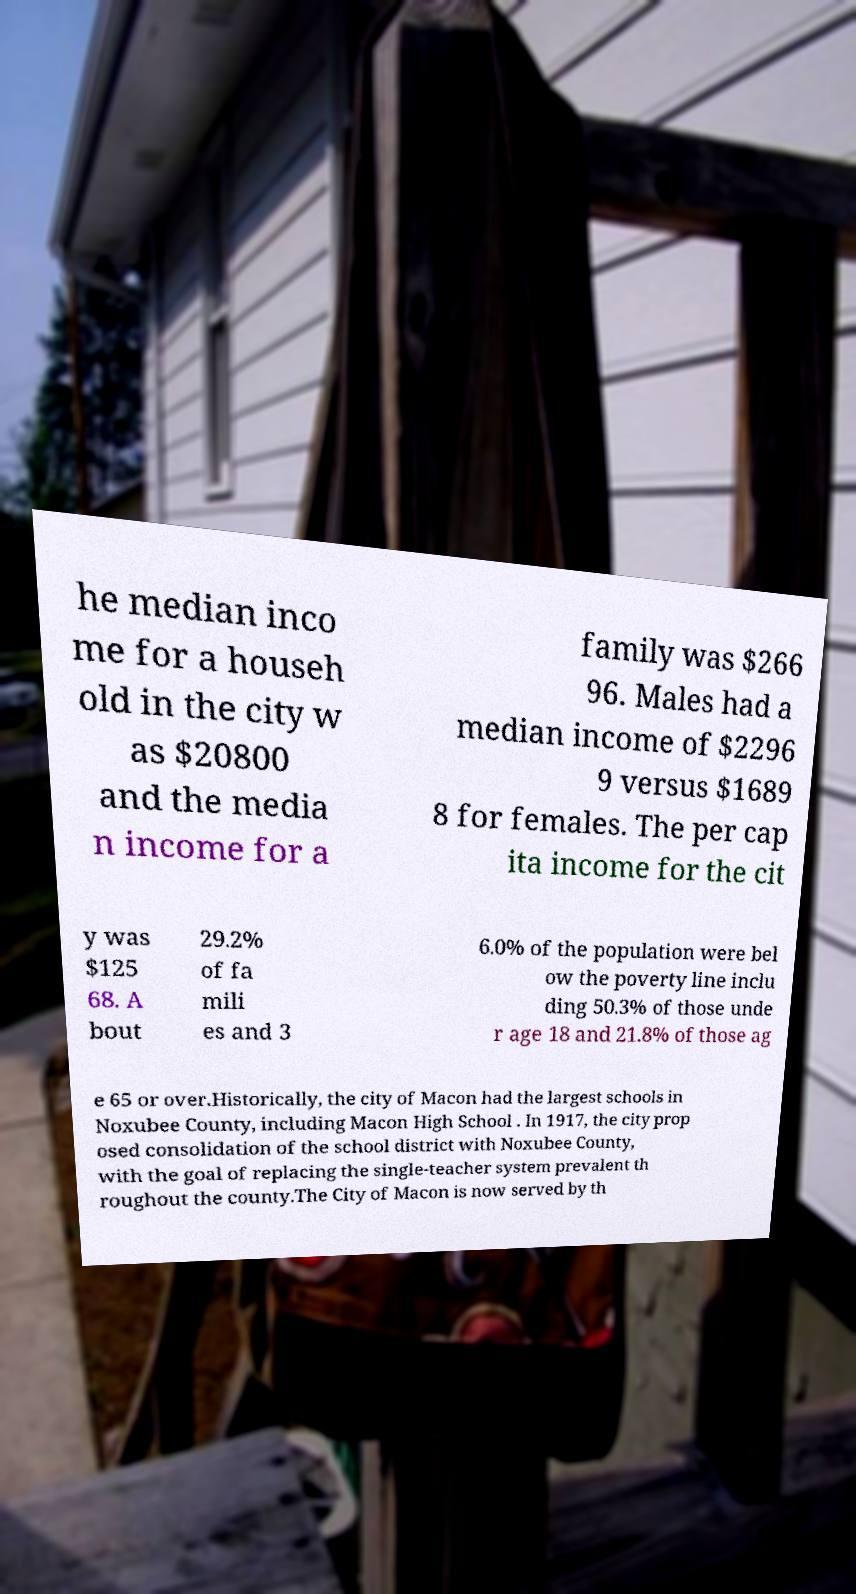Could you assist in decoding the text presented in this image and type it out clearly? he median inco me for a househ old in the city w as $20800 and the media n income for a family was $266 96. Males had a median income of $2296 9 versus $1689 8 for females. The per cap ita income for the cit y was $125 68. A bout 29.2% of fa mili es and 3 6.0% of the population were bel ow the poverty line inclu ding 50.3% of those unde r age 18 and 21.8% of those ag e 65 or over.Historically, the city of Macon had the largest schools in Noxubee County, including Macon High School . In 1917, the city prop osed consolidation of the school district with Noxubee County, with the goal of replacing the single-teacher system prevalent th roughout the county.The City of Macon is now served by th 